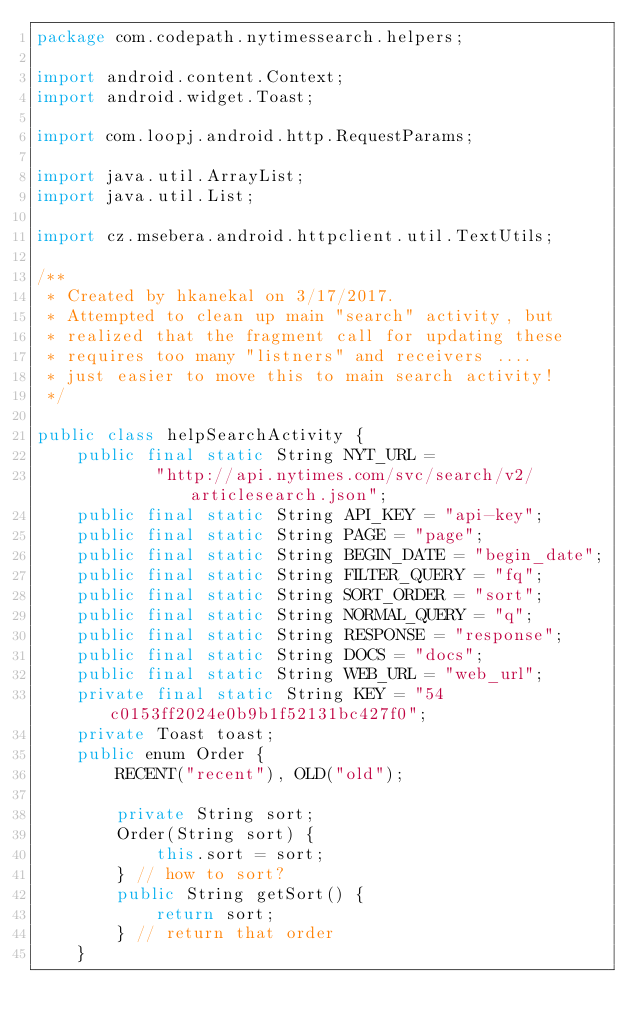Convert code to text. <code><loc_0><loc_0><loc_500><loc_500><_Java_>package com.codepath.nytimessearch.helpers;

import android.content.Context;
import android.widget.Toast;

import com.loopj.android.http.RequestParams;

import java.util.ArrayList;
import java.util.List;

import cz.msebera.android.httpclient.util.TextUtils;

/**
 * Created by hkanekal on 3/17/2017.
 * Attempted to clean up main "search" activity, but
 * realized that the fragment call for updating these
 * requires too many "listners" and receivers ....
 * just easier to move this to main search activity!
 */

public class helpSearchActivity {
    public final static String NYT_URL =
            "http://api.nytimes.com/svc/search/v2/articlesearch.json";
    public final static String API_KEY = "api-key";
    public final static String PAGE = "page";
    public final static String BEGIN_DATE = "begin_date";
    public final static String FILTER_QUERY = "fq";
    public final static String SORT_ORDER = "sort";
    public final static String NORMAL_QUERY = "q";
    public final static String RESPONSE = "response";
    public final static String DOCS = "docs";
    public final static String WEB_URL = "web_url";
    private final static String KEY = "54c0153ff2024e0b9b1f52131bc427f0";
    private Toast toast;
    public enum Order {
        RECENT("recent"), OLD("old");

        private String sort;
        Order(String sort) {
            this.sort = sort;
        } // how to sort?
        public String getSort() {
            return sort;
        } // return that order
    }
</code> 